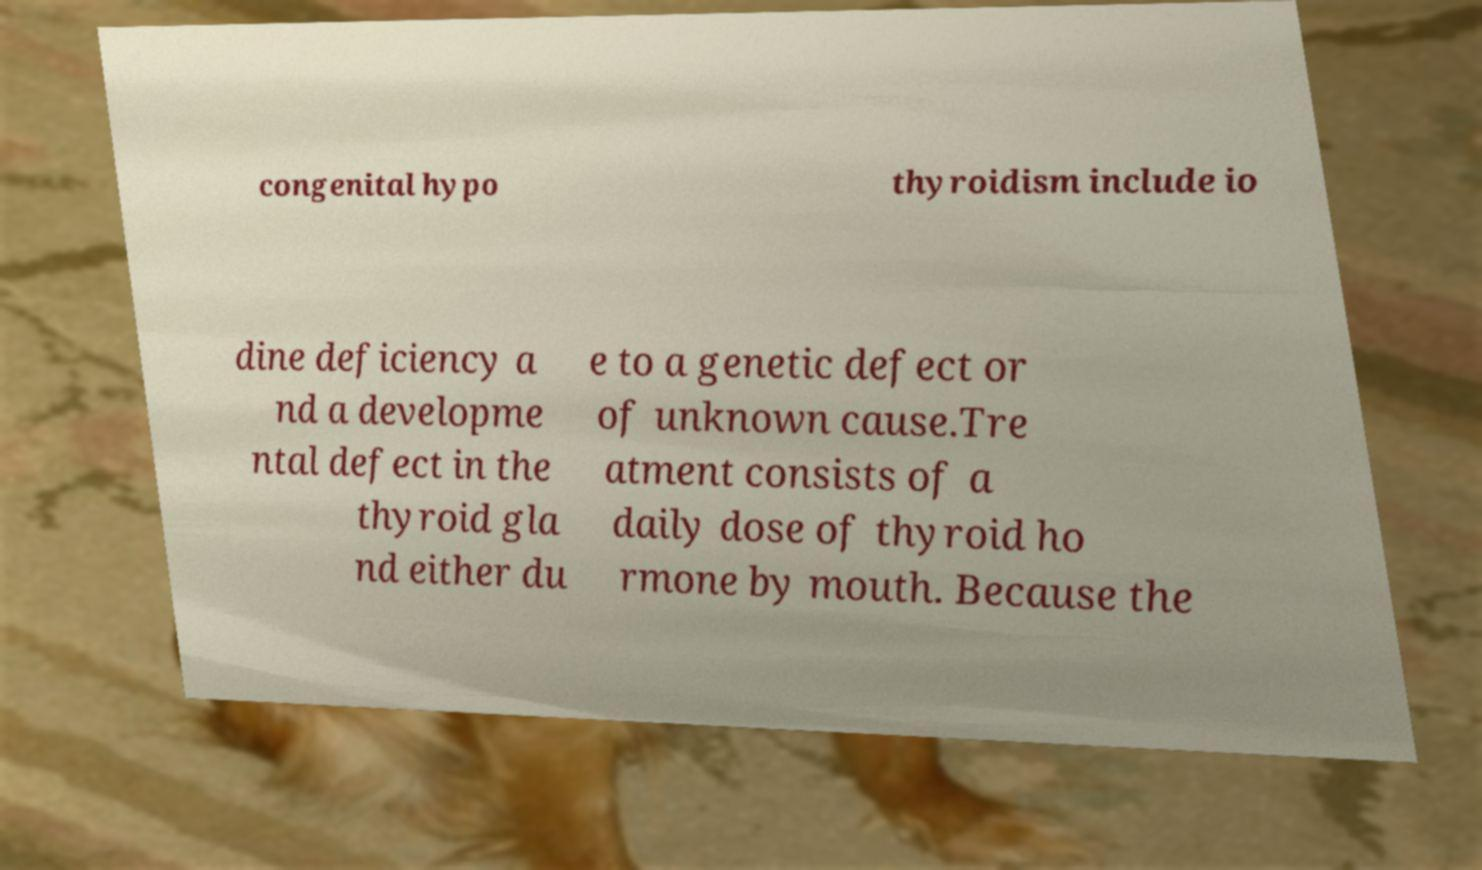Could you assist in decoding the text presented in this image and type it out clearly? congenital hypo thyroidism include io dine deficiency a nd a developme ntal defect in the thyroid gla nd either du e to a genetic defect or of unknown cause.Tre atment consists of a daily dose of thyroid ho rmone by mouth. Because the 